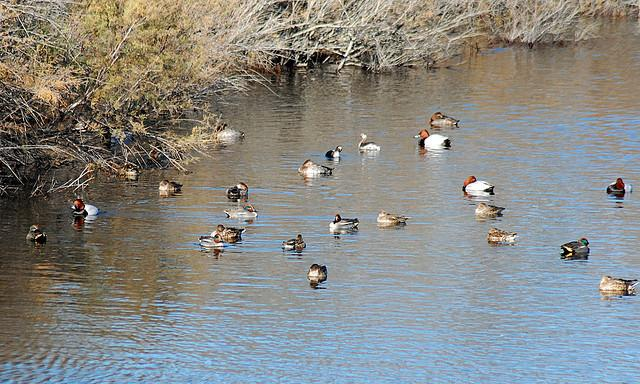What are the males called?

Choices:
A) roosters
B) cocks
C) gander
D) drakes drakes 